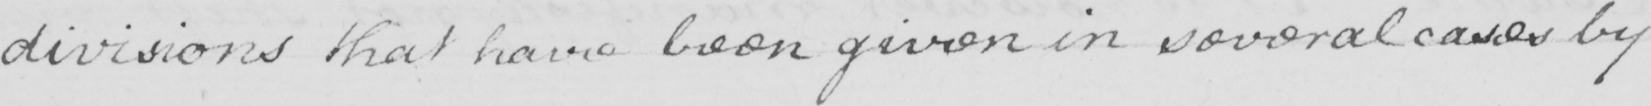What text is written in this handwritten line? divisions that have been given in several cases by 